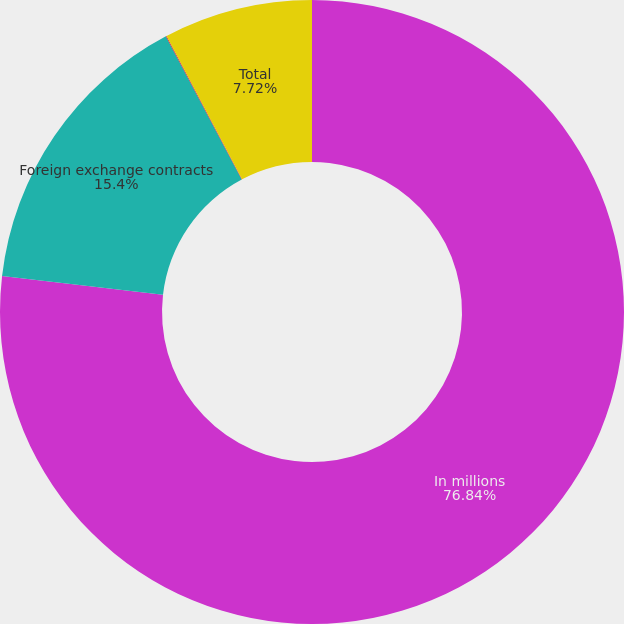<chart> <loc_0><loc_0><loc_500><loc_500><pie_chart><fcel>In millions<fcel>Foreign exchange contracts<fcel>Natural gas contracts<fcel>Total<nl><fcel>76.84%<fcel>15.4%<fcel>0.04%<fcel>7.72%<nl></chart> 